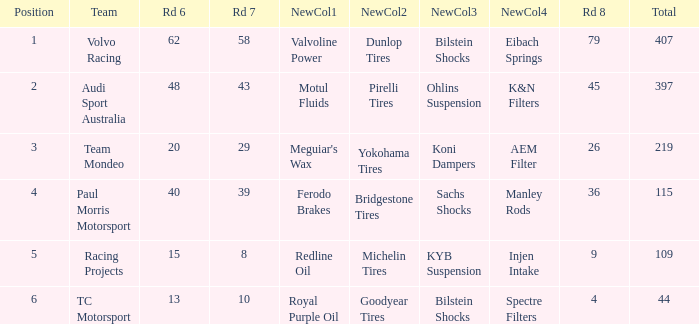What is the average value for Rd 8 in a position less than 2 for Audi Sport Australia? None. 